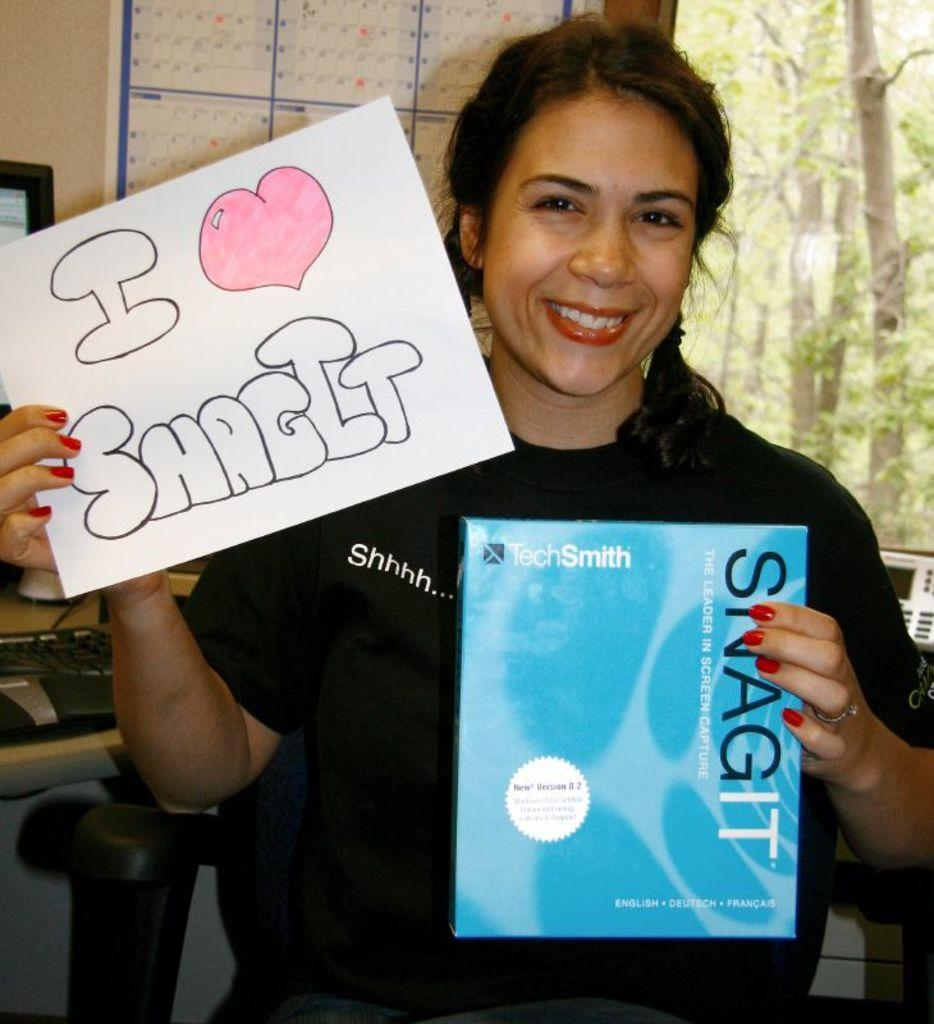What is the woman in the image doing? The woman is standing in the image and holding posters. What is behind the woman in the image? There is a wall behind the woman. What electronic devices are present in the image? There is a keyboard and a system in the image. What type of natural scenery can be seen in the image? Trees are visible in the image. What type of light is being used to illuminate the baby in the image? There is no baby present in the image, so it is not possible to determine what type of light might be used to illuminate a baby. 